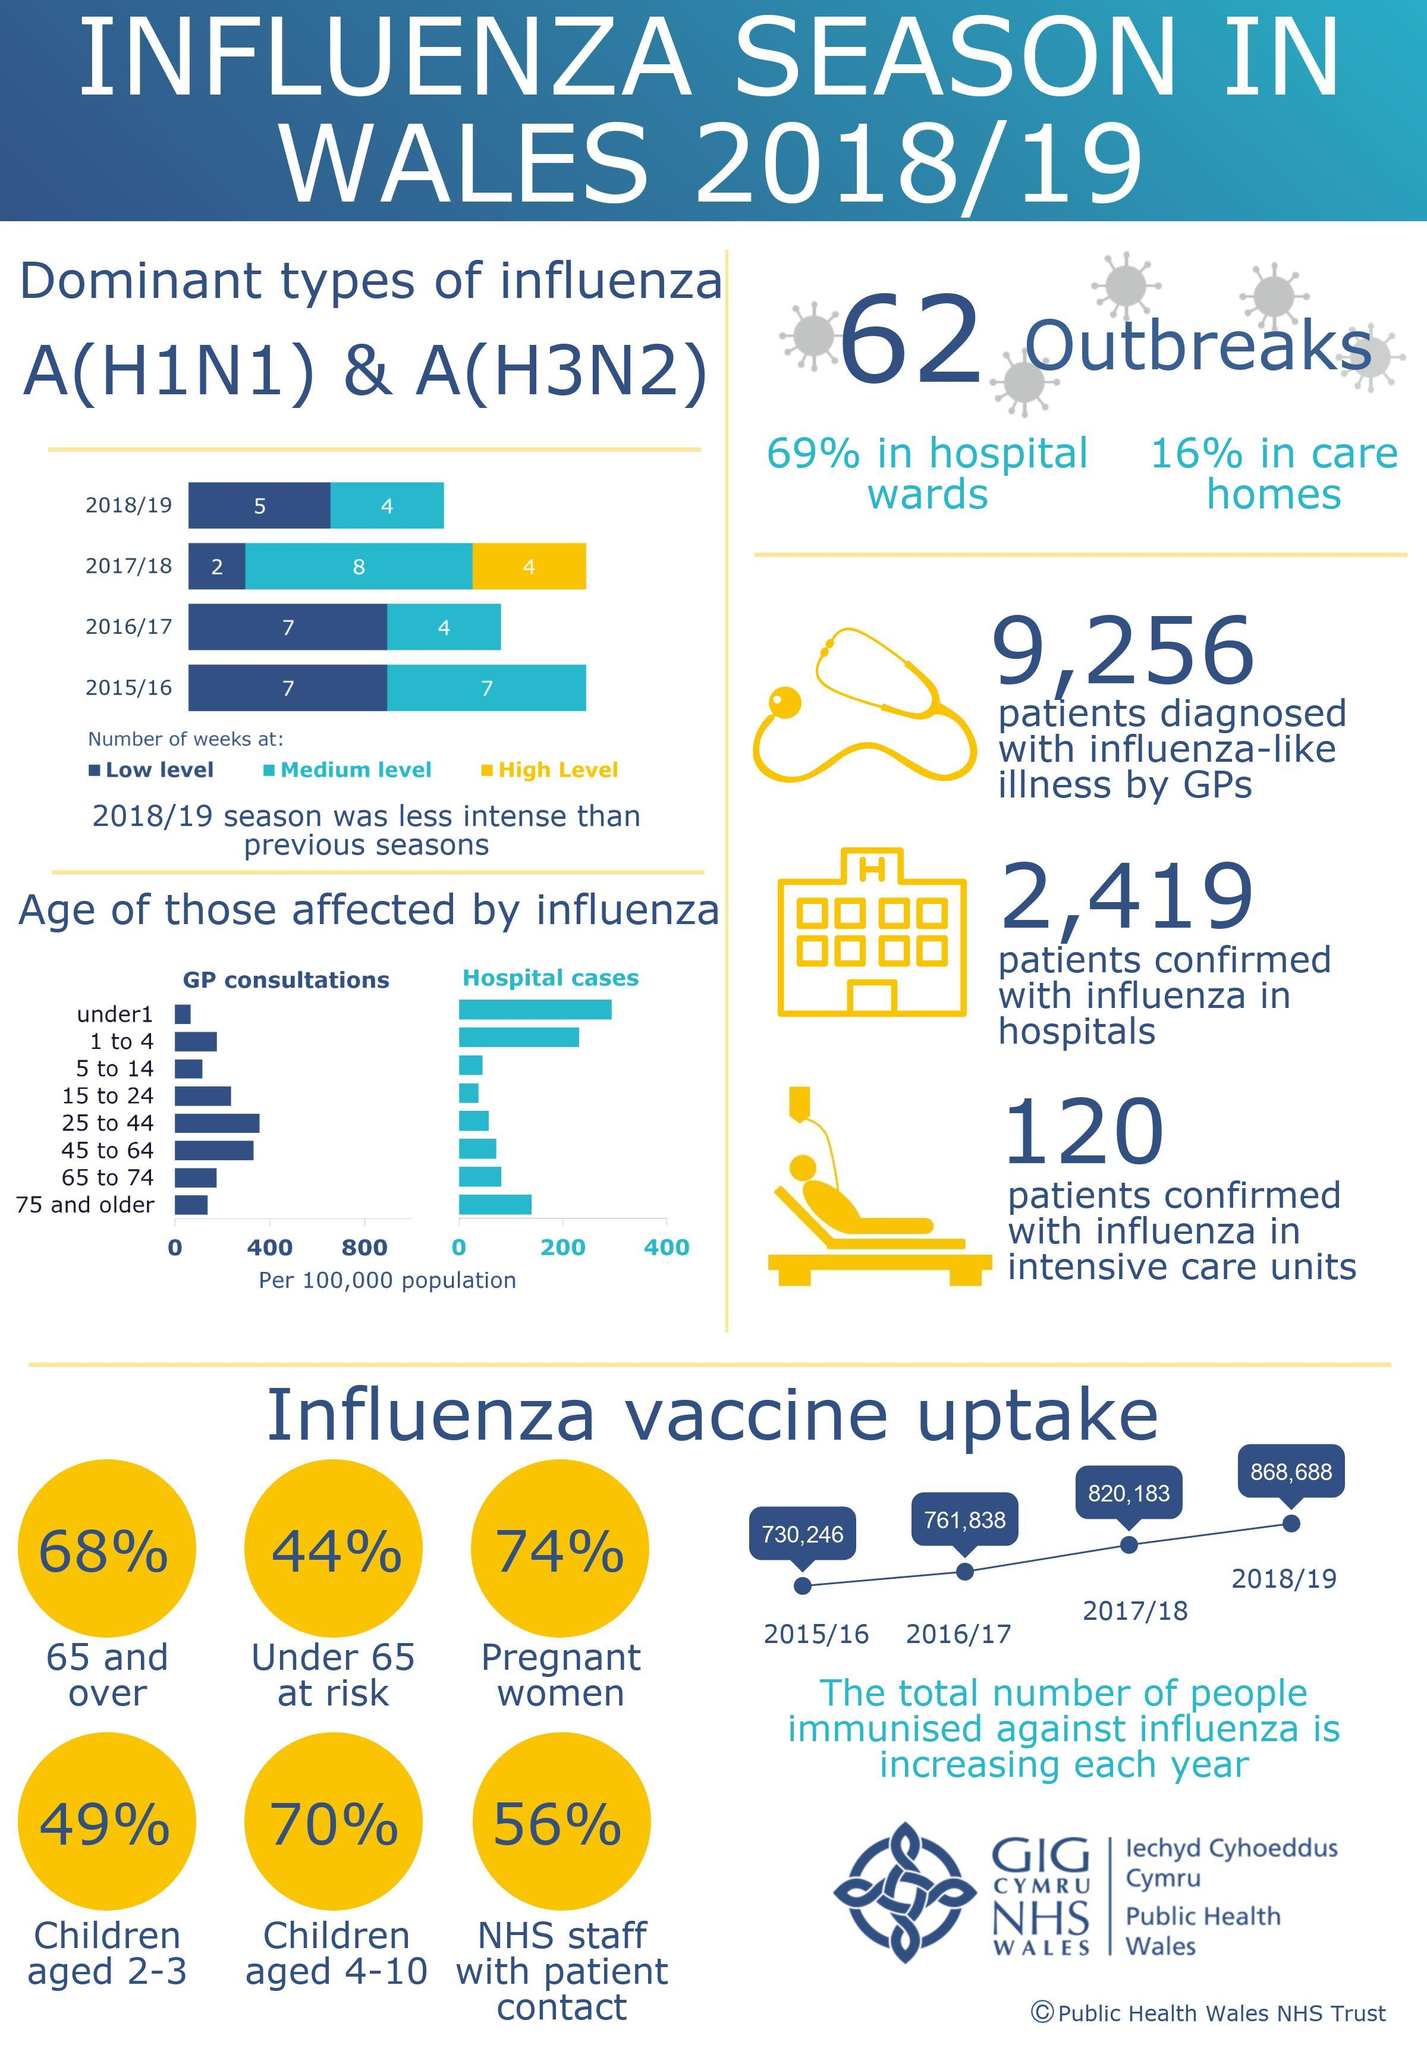By what number did total number of people immunized against influenza increase from 2017/18 to 2018/19?
Answer the question with a short phrase. 48,505 In the bar chart, what does yellow bar represent? High Level What percent of expectant mothers are immunized? 74% What percent of senior citizens are immunized against influenza? 68% 